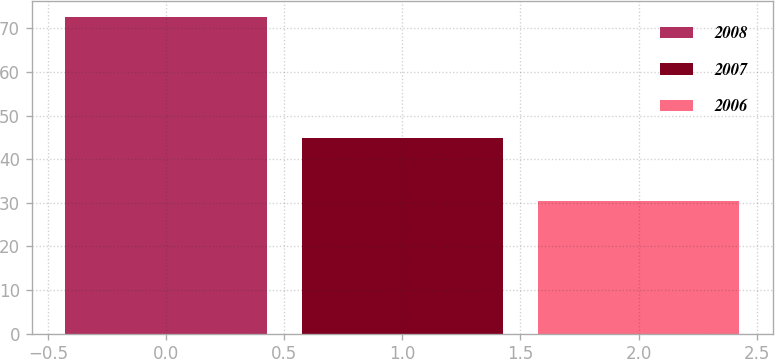Convert chart. <chart><loc_0><loc_0><loc_500><loc_500><bar_chart><fcel>2008<fcel>2007<fcel>2006<nl><fcel>72.7<fcel>44.8<fcel>30.4<nl></chart> 